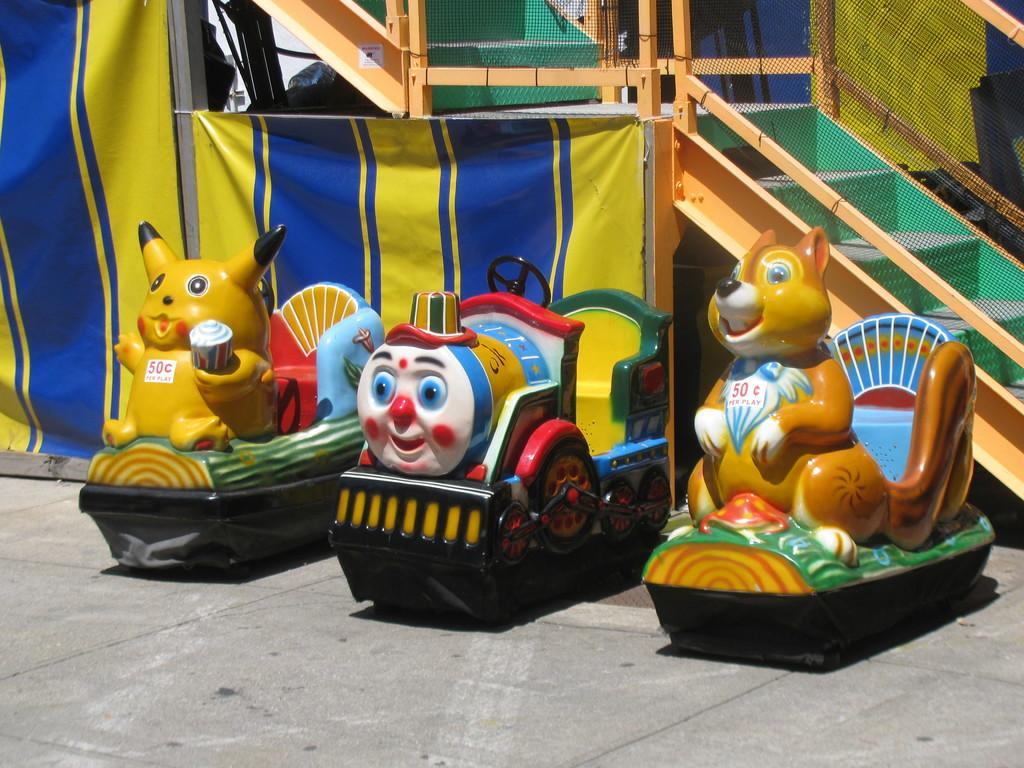In one or two sentences, can you explain what this image depicts? In this picture I can see there are toys and in the backdrop, there are wooden stairs with a railing and a net. 